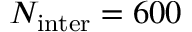Convert formula to latex. <formula><loc_0><loc_0><loc_500><loc_500>N _ { i n t e r } = 6 0 0</formula> 